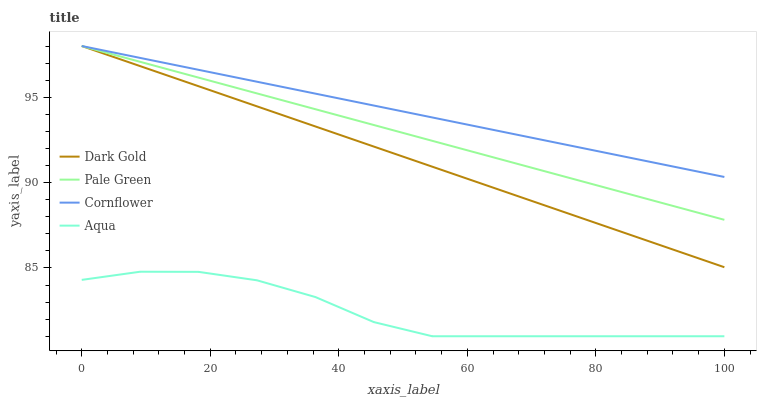Does Aqua have the minimum area under the curve?
Answer yes or no. Yes. Does Cornflower have the maximum area under the curve?
Answer yes or no. Yes. Does Pale Green have the minimum area under the curve?
Answer yes or no. No. Does Pale Green have the maximum area under the curve?
Answer yes or no. No. Is Dark Gold the smoothest?
Answer yes or no. Yes. Is Aqua the roughest?
Answer yes or no. Yes. Is Pale Green the smoothest?
Answer yes or no. No. Is Pale Green the roughest?
Answer yes or no. No. Does Aqua have the lowest value?
Answer yes or no. Yes. Does Pale Green have the lowest value?
Answer yes or no. No. Does Dark Gold have the highest value?
Answer yes or no. Yes. Does Aqua have the highest value?
Answer yes or no. No. Is Aqua less than Dark Gold?
Answer yes or no. Yes. Is Pale Green greater than Aqua?
Answer yes or no. Yes. Does Dark Gold intersect Pale Green?
Answer yes or no. Yes. Is Dark Gold less than Pale Green?
Answer yes or no. No. Is Dark Gold greater than Pale Green?
Answer yes or no. No. Does Aqua intersect Dark Gold?
Answer yes or no. No. 